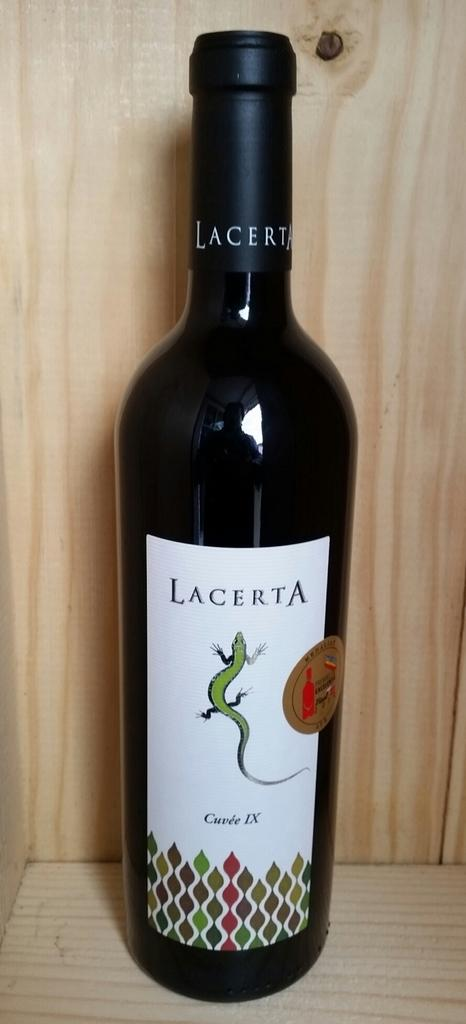<image>
Describe the image concisely. Lacerta bottle of wine that has text on it saying Cuvee IX. 